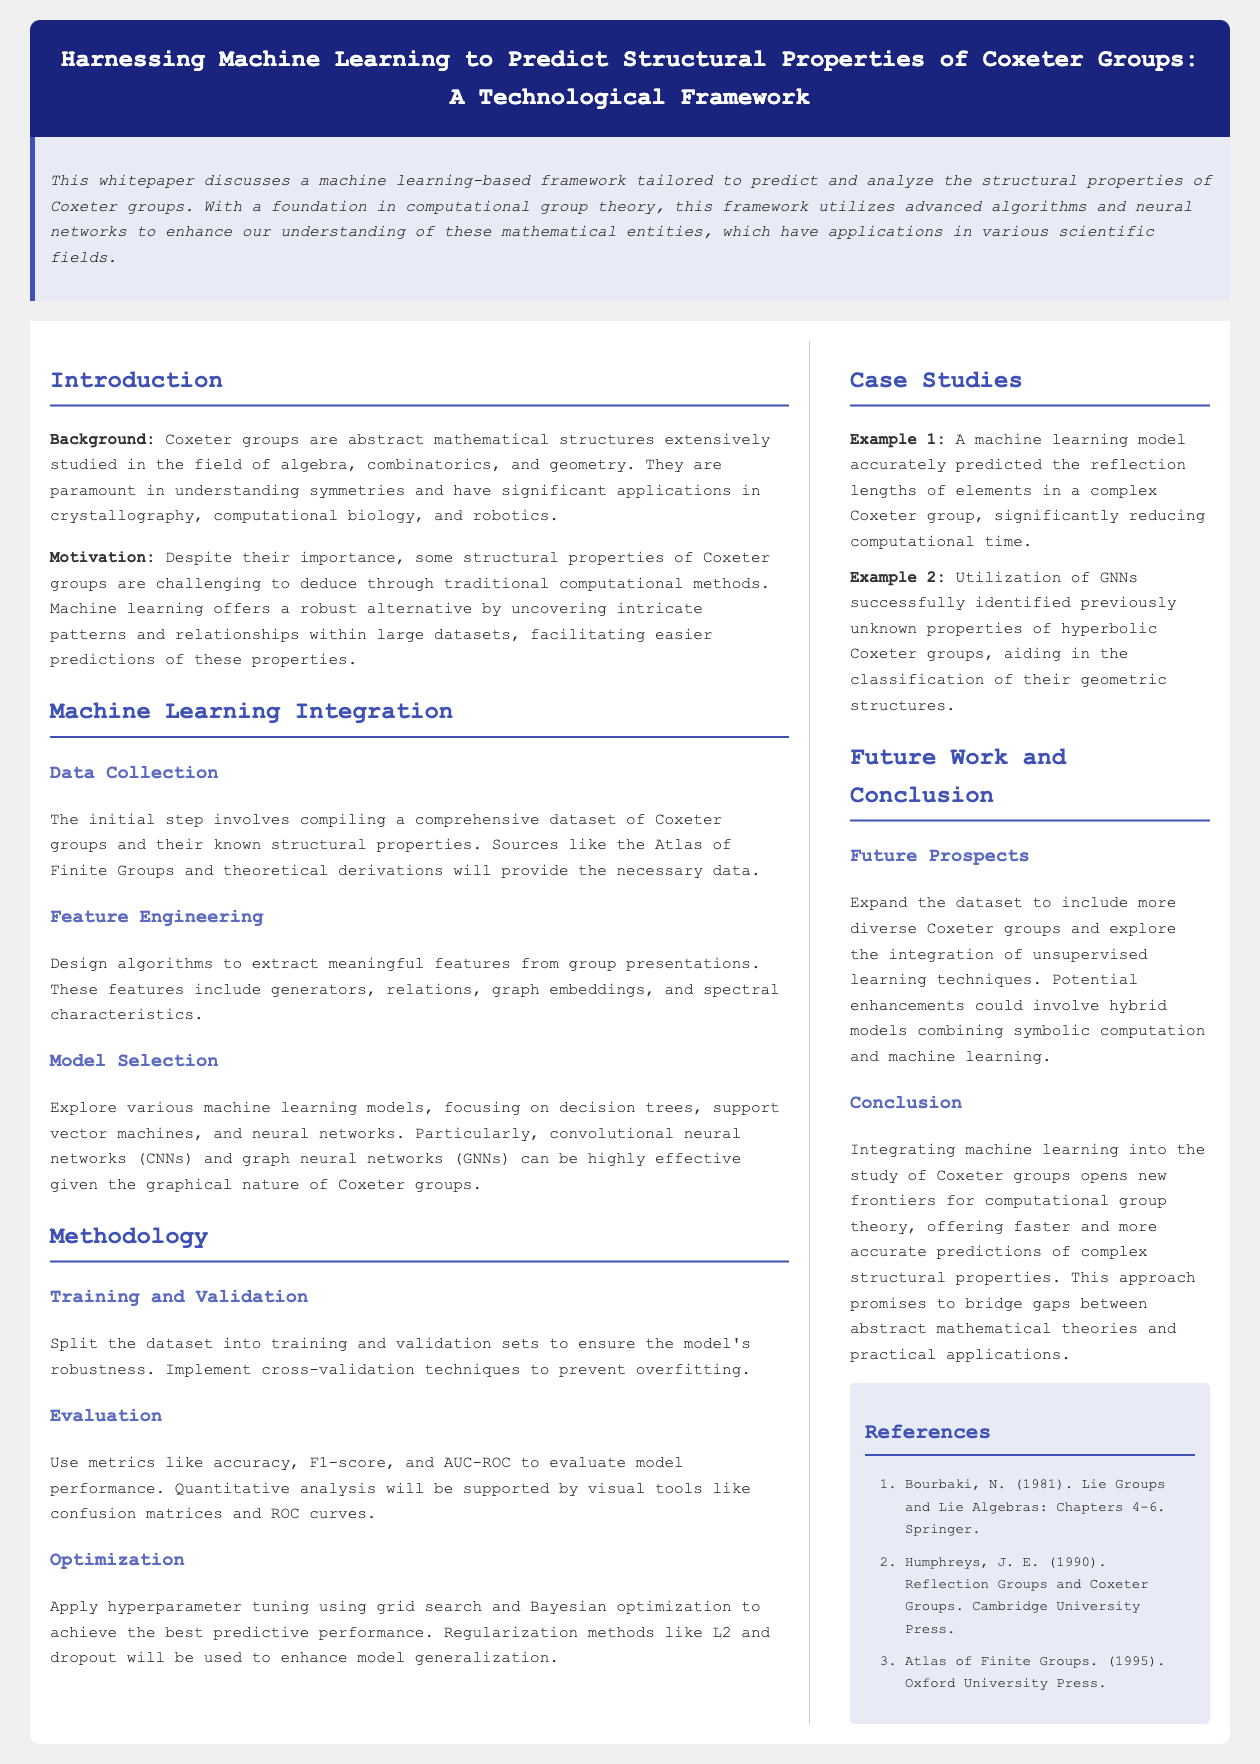What is the title of the whitepaper? The title is the main heading presented at the top of the document in the header section.
Answer: Harnessing Machine Learning to Predict Structural Properties of Coxeter Groups: A Technological Framework What are Coxeter groups primarily studied in? This is found in the introduction, outlining the main fields where Coxeter groups have significance.
Answer: Algebra, combinatorics, and geometry Which machine learning models are highlighted in the document? This is extracted from the model selection section, listing the models considered for the study.
Answer: Decision trees, support vector machines, and neural networks What provides the initial dataset for Coxeter groups? The data sources are mentioned in the data collection subsection of the methodology.
Answer: The Atlas of Finite Groups and theoretical derivations What is one quantitative evaluation metric mentioned? This can be found in the evaluation section, where various metrics for performance are identified.
Answer: Accuracy What is a potential future enhancement for the study? The future prospects section suggests an area of exploration for subsequent research.
Answer: Hybrid models combining symbolic computation and machine learning What type of neural networks does the framework emphasize? This is specified in the model selection subsection discussing effective models for Coxeter groups.
Answer: Convolutional neural networks (CNNs) and graph neural networks (GNNs) Which case study highlighted the prediction of reflection lengths? The case studies section lists examples, identifying specific studies conducted.
Answer: Example 1 